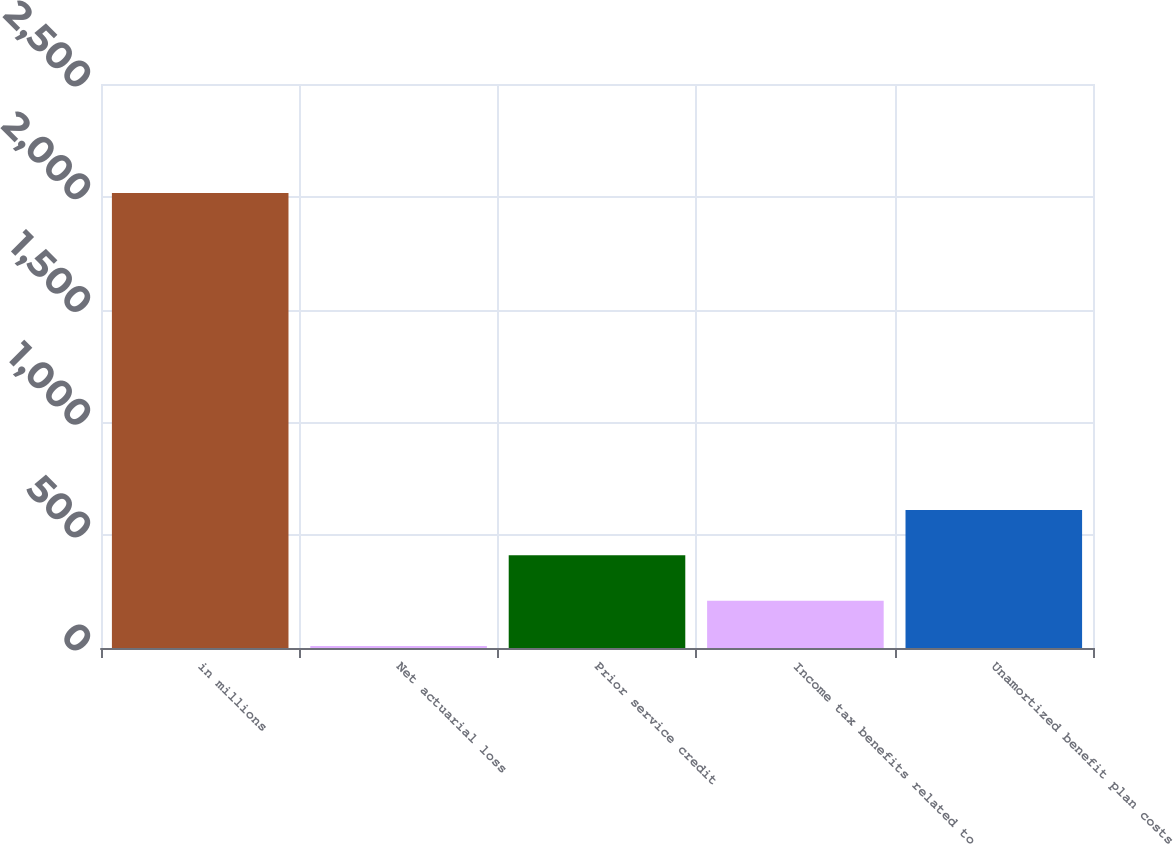Convert chart. <chart><loc_0><loc_0><loc_500><loc_500><bar_chart><fcel>in millions<fcel>Net actuarial loss<fcel>Prior service credit<fcel>Income tax benefits related to<fcel>Unamortized benefit plan costs<nl><fcel>2017<fcel>9<fcel>410.6<fcel>209.8<fcel>611.4<nl></chart> 